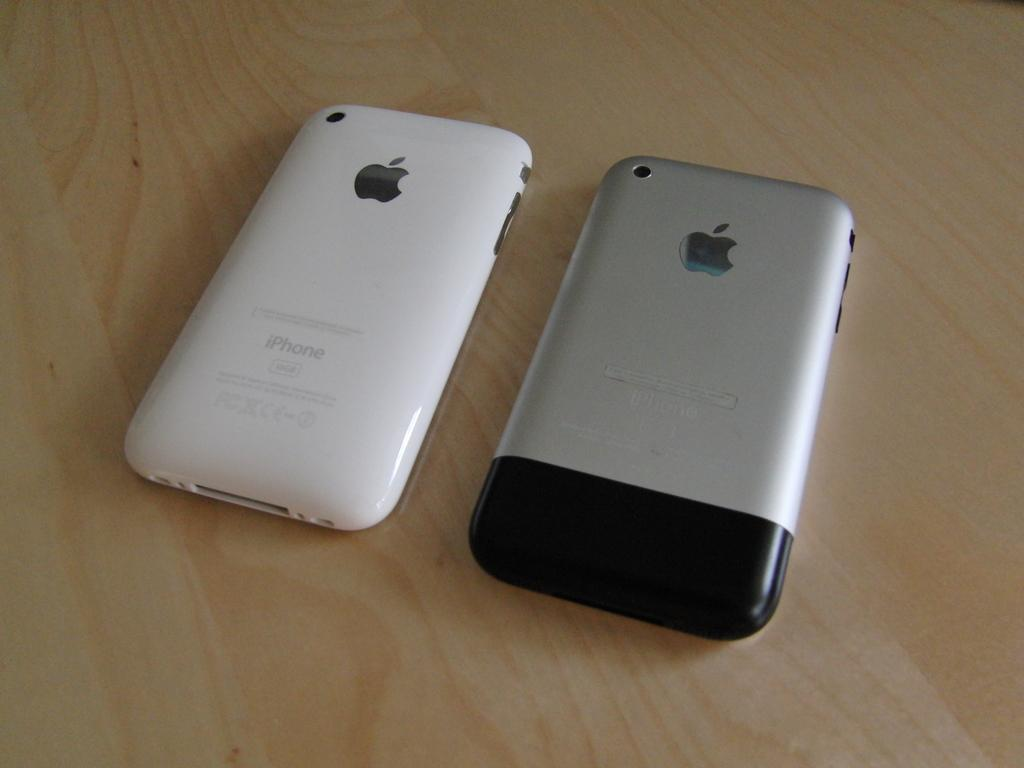<image>
Give a short and clear explanation of the subsequent image. The back of an iPhone and the white one is 16GB. 